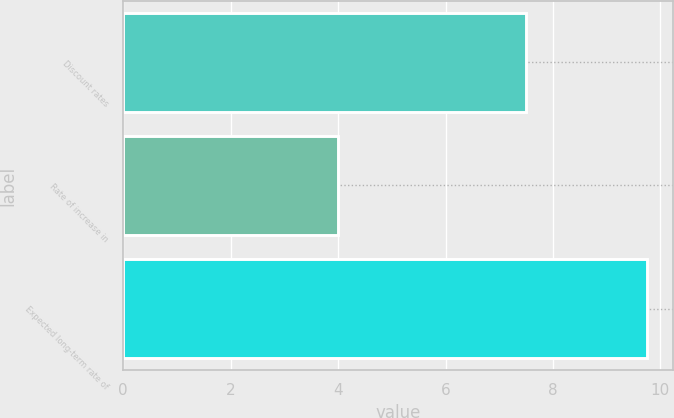Convert chart to OTSL. <chart><loc_0><loc_0><loc_500><loc_500><bar_chart><fcel>Discount rates<fcel>Rate of increase in<fcel>Expected long-term rate of<nl><fcel>7.5<fcel>4<fcel>9.75<nl></chart> 